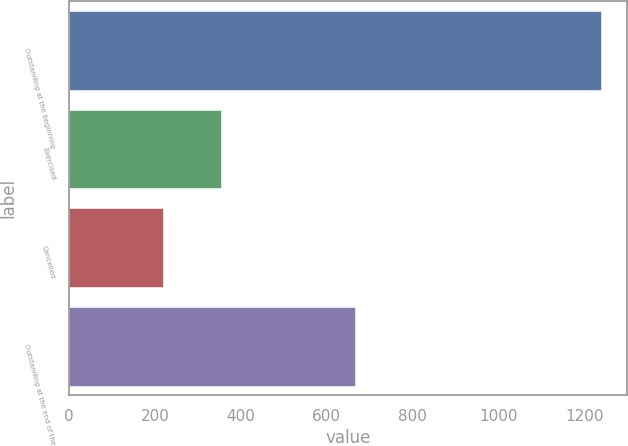<chart> <loc_0><loc_0><loc_500><loc_500><bar_chart><fcel>Outstanding at the beginning<fcel>Exercised<fcel>Cancelled<fcel>Outstanding at the end of the<nl><fcel>1238<fcel>354<fcel>218<fcel>666<nl></chart> 